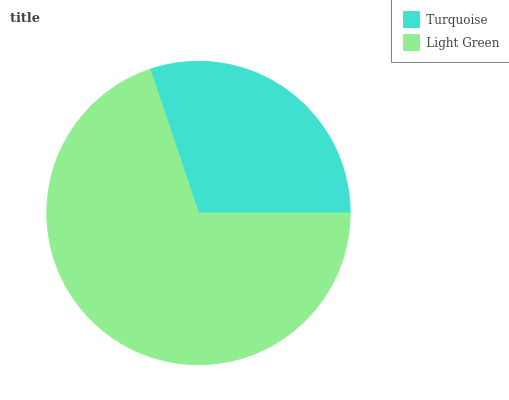Is Turquoise the minimum?
Answer yes or no. Yes. Is Light Green the maximum?
Answer yes or no. Yes. Is Light Green the minimum?
Answer yes or no. No. Is Light Green greater than Turquoise?
Answer yes or no. Yes. Is Turquoise less than Light Green?
Answer yes or no. Yes. Is Turquoise greater than Light Green?
Answer yes or no. No. Is Light Green less than Turquoise?
Answer yes or no. No. Is Light Green the high median?
Answer yes or no. Yes. Is Turquoise the low median?
Answer yes or no. Yes. Is Turquoise the high median?
Answer yes or no. No. Is Light Green the low median?
Answer yes or no. No. 